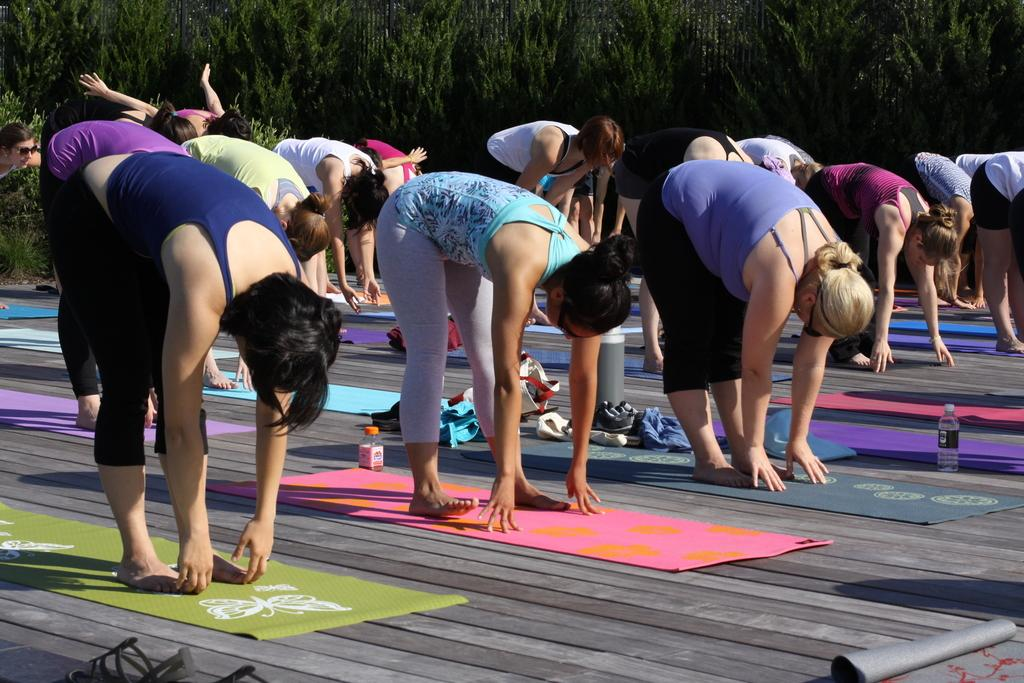Who or what can be seen in the image? There are people in the image. What are the people doing in the image? The people are exercising on mats. What can be seen in the background of the image? There are trees in the background of the image. What type of oven is being advertised in the image? There is no oven or advertisement present in the image; it features people exercising on mats with trees in the background. Can you spot an owl in the image? There is no owl present in the image. 